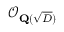Convert formula to latex. <formula><loc_0><loc_0><loc_500><loc_500>{ \mathcal { O } } _ { Q ( { \sqrt { D } } ) }</formula> 